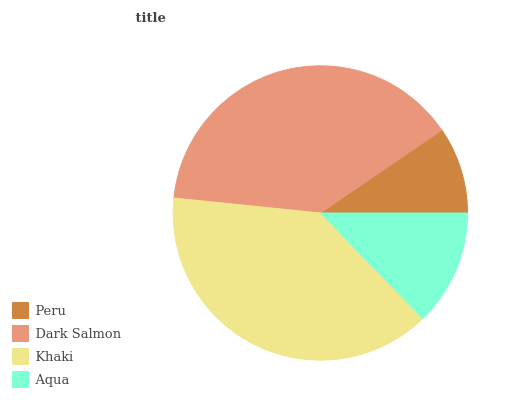Is Peru the minimum?
Answer yes or no. Yes. Is Khaki the maximum?
Answer yes or no. Yes. Is Dark Salmon the minimum?
Answer yes or no. No. Is Dark Salmon the maximum?
Answer yes or no. No. Is Dark Salmon greater than Peru?
Answer yes or no. Yes. Is Peru less than Dark Salmon?
Answer yes or no. Yes. Is Peru greater than Dark Salmon?
Answer yes or no. No. Is Dark Salmon less than Peru?
Answer yes or no. No. Is Dark Salmon the high median?
Answer yes or no. Yes. Is Aqua the low median?
Answer yes or no. Yes. Is Aqua the high median?
Answer yes or no. No. Is Khaki the low median?
Answer yes or no. No. 